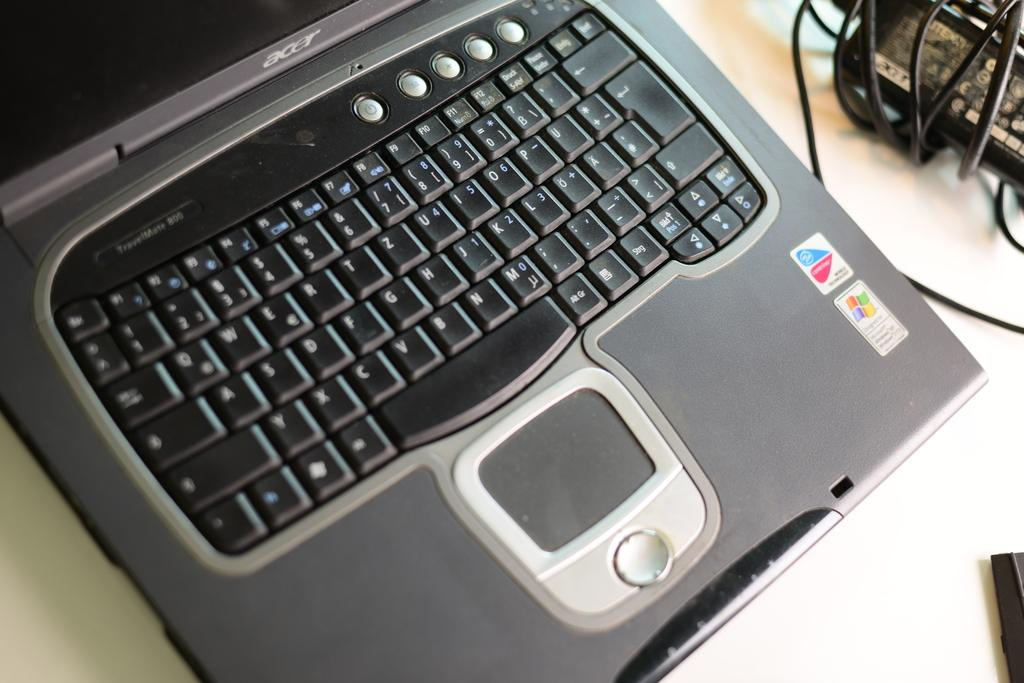<image>
Provide a brief description of the given image. An open acer laptop showcasing the keyboard and mouse as well as a windows sticker. 